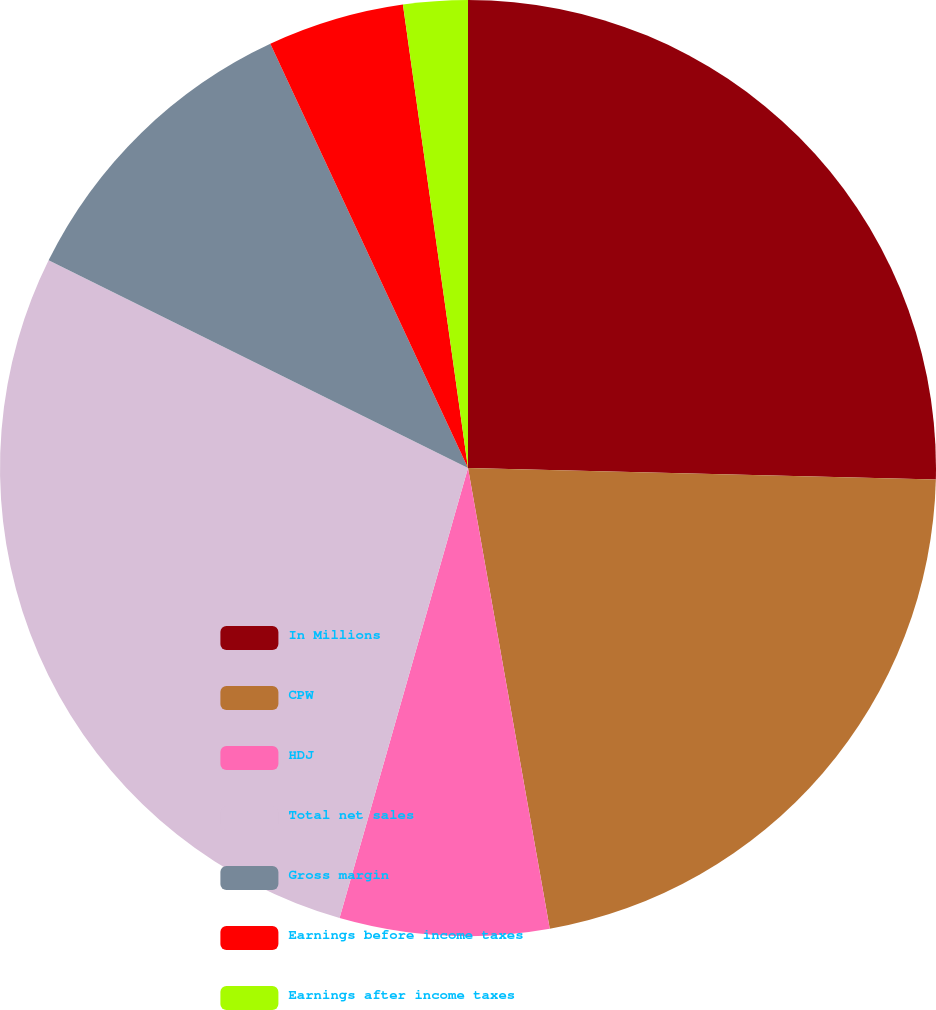Convert chart to OTSL. <chart><loc_0><loc_0><loc_500><loc_500><pie_chart><fcel>In Millions<fcel>CPW<fcel>HDJ<fcel>Total net sales<fcel>Gross margin<fcel>Earnings before income taxes<fcel>Earnings after income taxes<nl><fcel>25.39%<fcel>21.81%<fcel>7.22%<fcel>27.89%<fcel>10.74%<fcel>4.72%<fcel>2.22%<nl></chart> 